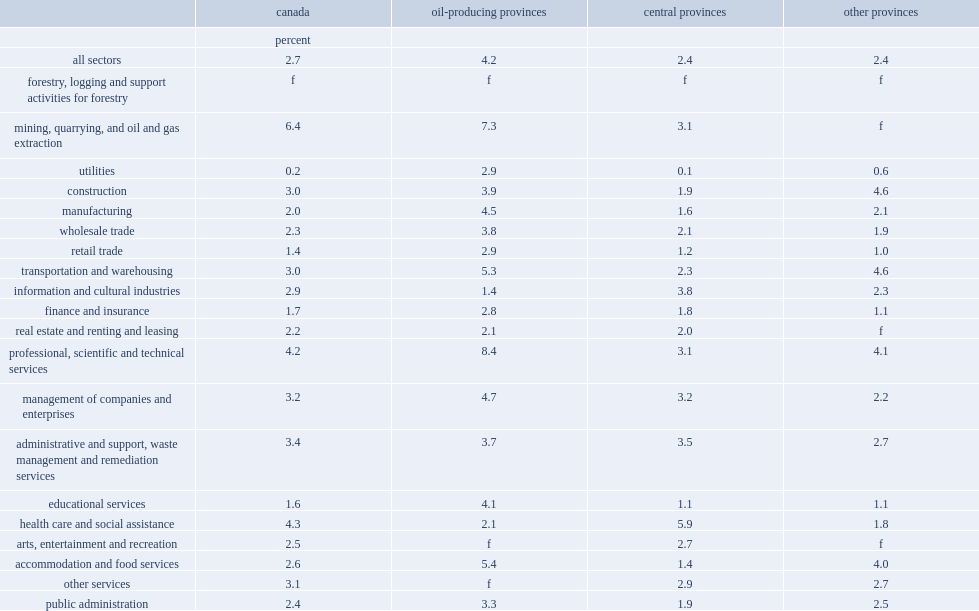Which province posted the highest job vacancy rates in the professional, scientific and technical services sector? Oil-producing provinces. 